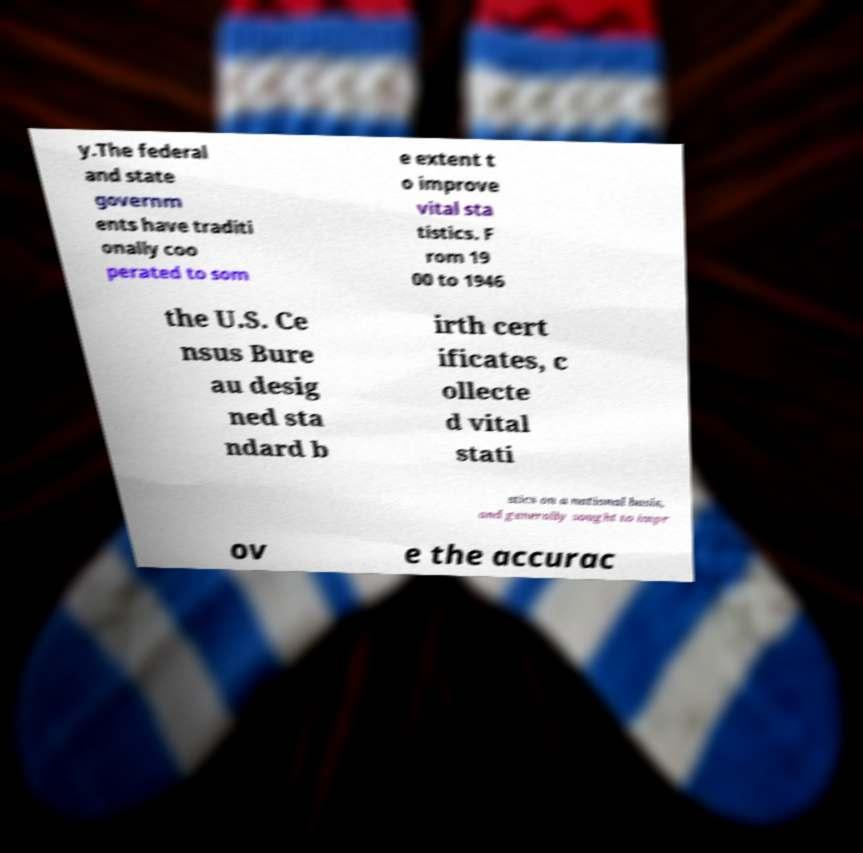What messages or text are displayed in this image? I need them in a readable, typed format. y.The federal and state governm ents have traditi onally coo perated to som e extent t o improve vital sta tistics. F rom 19 00 to 1946 the U.S. Ce nsus Bure au desig ned sta ndard b irth cert ificates, c ollecte d vital stati stics on a national basis, and generally sought to impr ov e the accurac 